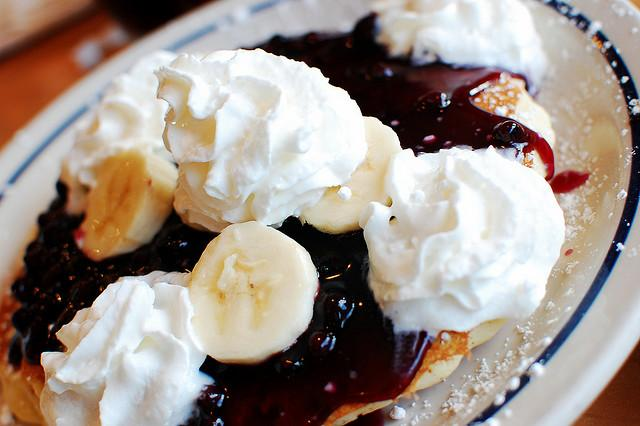What type of breakfast food is this on the plate? Please explain your reasoning. pancake. The pancake is plated. 